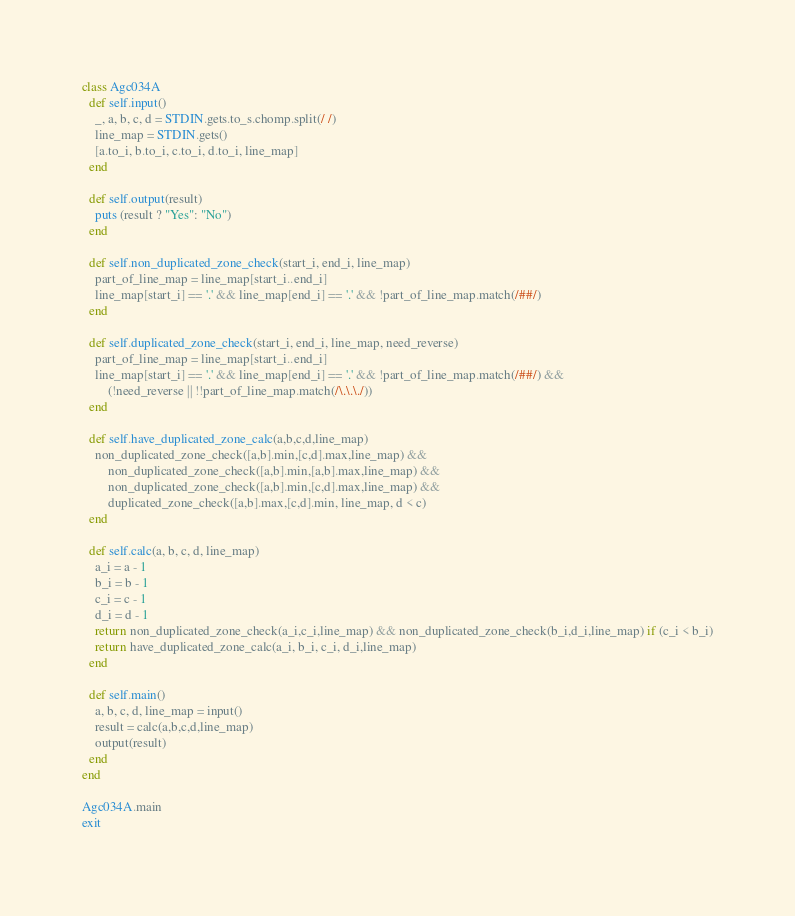Convert code to text. <code><loc_0><loc_0><loc_500><loc_500><_Ruby_>

class Agc034A
  def self.input()
    _, a, b, c, d = STDIN.gets.to_s.chomp.split(/ /)
    line_map = STDIN.gets()
    [a.to_i, b.to_i, c.to_i, d.to_i, line_map]
  end

  def self.output(result)
    puts (result ? "Yes": "No")
  end

  def self.non_duplicated_zone_check(start_i, end_i, line_map)
    part_of_line_map = line_map[start_i..end_i]
    line_map[start_i] == '.' && line_map[end_i] == '.' && !part_of_line_map.match(/##/)
  end

  def self.duplicated_zone_check(start_i, end_i, line_map, need_reverse)
    part_of_line_map = line_map[start_i..end_i]
    line_map[start_i] == '.' && line_map[end_i] == '.' && !part_of_line_map.match(/##/) &&
        (!need_reverse || !!part_of_line_map.match(/\.\.\./))
  end

  def self.have_duplicated_zone_calc(a,b,c,d,line_map)
    non_duplicated_zone_check([a,b].min,[c,d].max,line_map) &&
        non_duplicated_zone_check([a,b].min,[a,b].max,line_map) &&
        non_duplicated_zone_check([a,b].min,[c,d].max,line_map) &&
        duplicated_zone_check([a,b].max,[c,d].min, line_map, d < c)
  end

  def self.calc(a, b, c, d, line_map)
    a_i = a - 1
    b_i = b - 1
    c_i = c - 1
    d_i = d - 1
    return non_duplicated_zone_check(a_i,c_i,line_map) && non_duplicated_zone_check(b_i,d_i,line_map) if (c_i < b_i)
    return have_duplicated_zone_calc(a_i, b_i, c_i, d_i,line_map)
  end

  def self.main()
    a, b, c, d, line_map = input()
    result = calc(a,b,c,d,line_map)
    output(result)
  end
end

Agc034A.main
exit</code> 